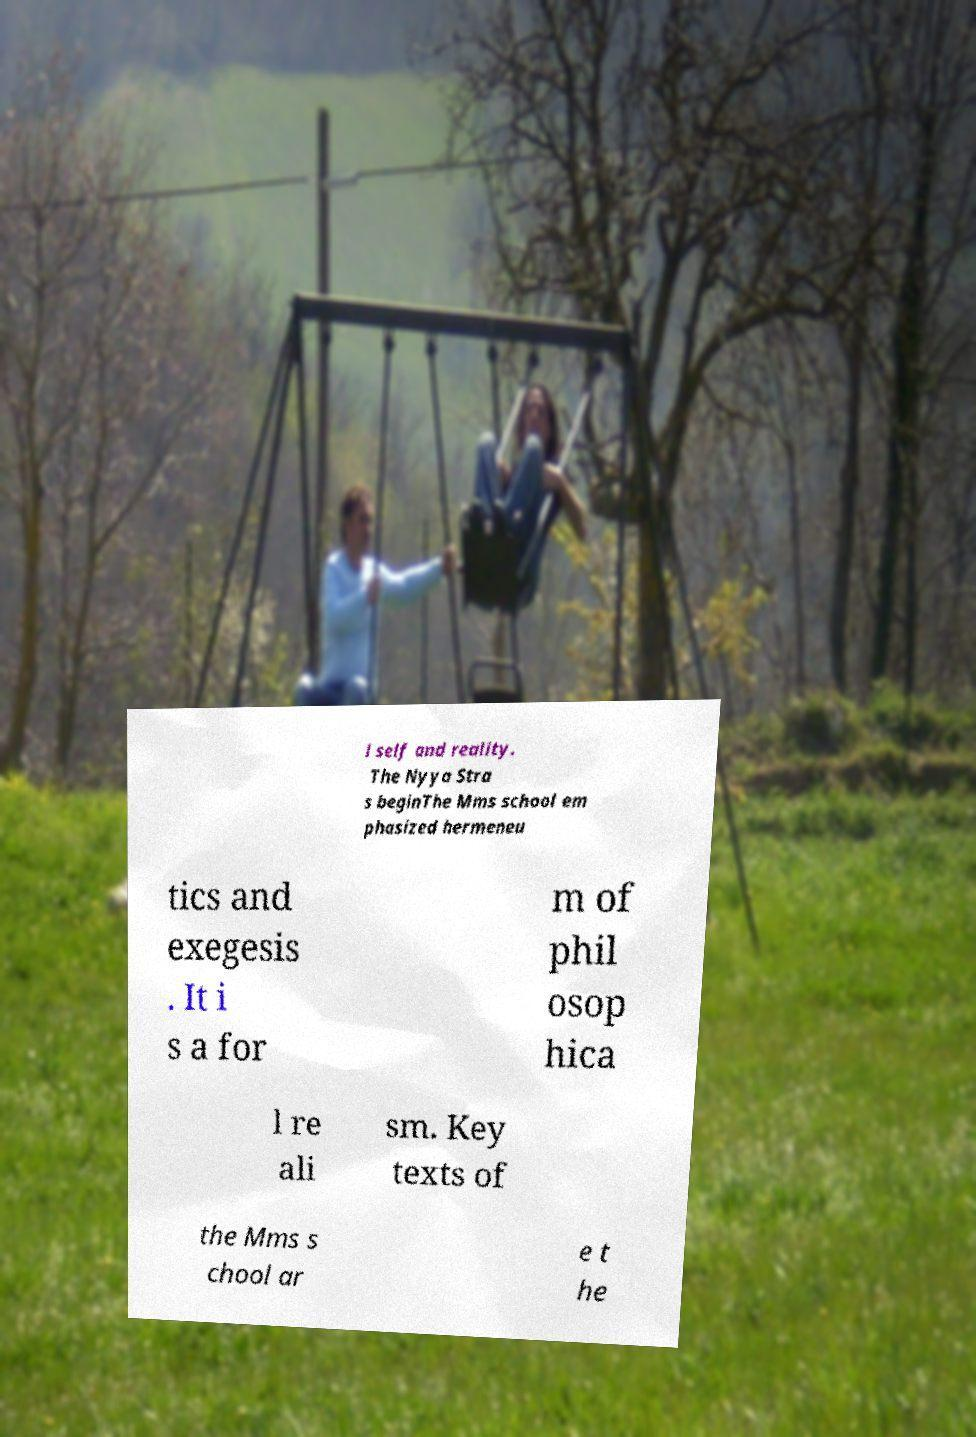Can you accurately transcribe the text from the provided image for me? l self and reality. The Nyya Stra s beginThe Mms school em phasized hermeneu tics and exegesis . It i s a for m of phil osop hica l re ali sm. Key texts of the Mms s chool ar e t he 